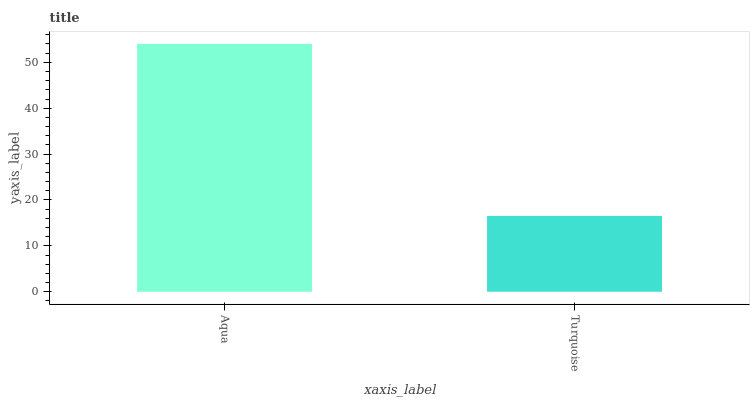Is Turquoise the minimum?
Answer yes or no. Yes. Is Aqua the maximum?
Answer yes or no. Yes. Is Turquoise the maximum?
Answer yes or no. No. Is Aqua greater than Turquoise?
Answer yes or no. Yes. Is Turquoise less than Aqua?
Answer yes or no. Yes. Is Turquoise greater than Aqua?
Answer yes or no. No. Is Aqua less than Turquoise?
Answer yes or no. No. Is Aqua the high median?
Answer yes or no. Yes. Is Turquoise the low median?
Answer yes or no. Yes. Is Turquoise the high median?
Answer yes or no. No. Is Aqua the low median?
Answer yes or no. No. 